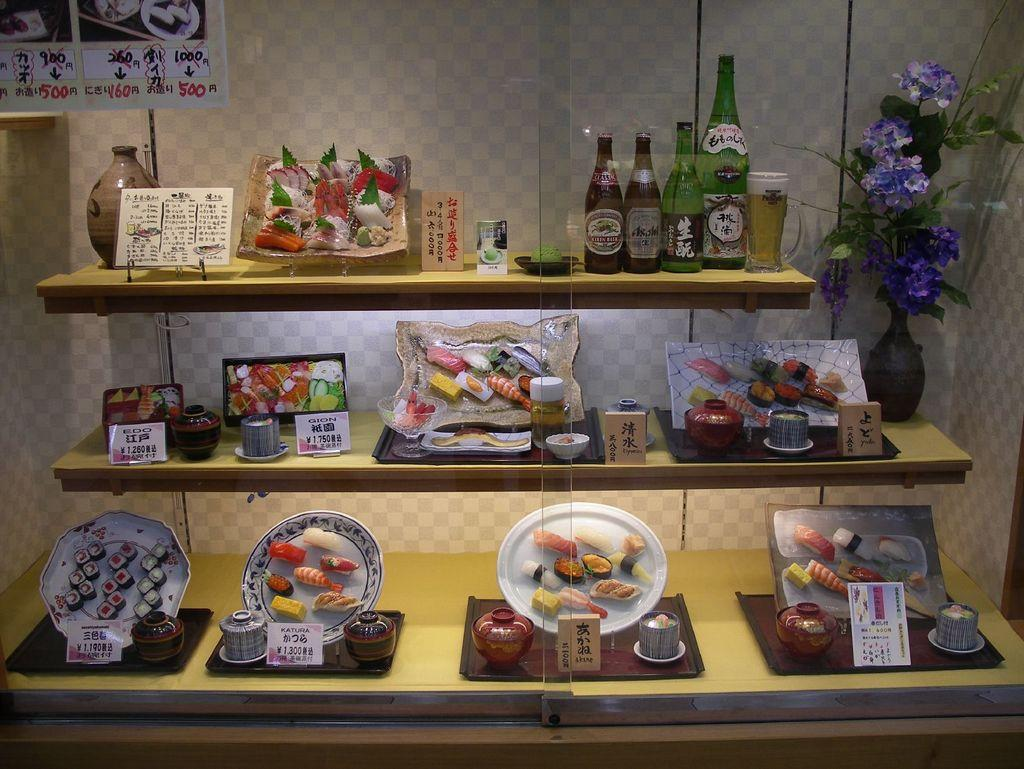What type of objects can be seen in the image? There are plates, food items, boards, trays, bottles, a flower pot, and objects on shelves visible in the image. What might be used for serving or holding food in the image? Plates, trays, and boards can be used for serving or holding food in the image. What can be found on the shelves in the image? There are objects on shelves in the image. What is the background of the image made of? There is a wall visible in the image, which serves as the background. What type of agreement was reached during the battle depicted in the image? There is no battle or agreement depicted in the image; it features various objects related to serving and holding food, as well as objects on shelves and a wall as the background. 